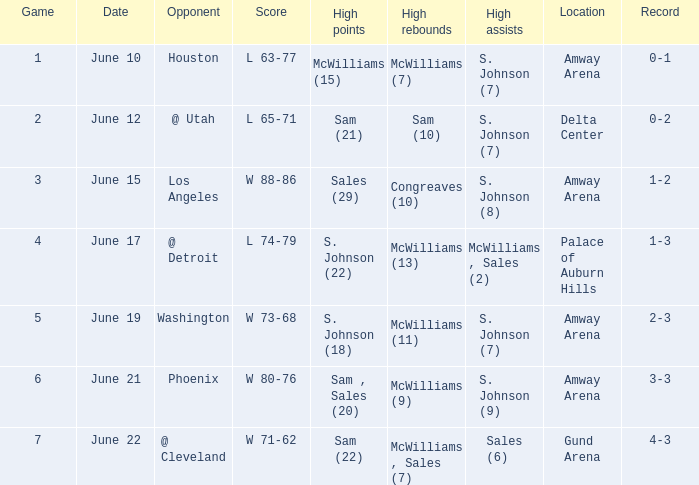Name the opponent for june 12 @ Utah. 